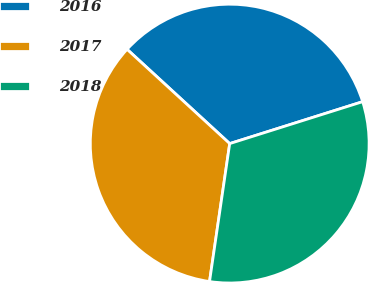Convert chart. <chart><loc_0><loc_0><loc_500><loc_500><pie_chart><fcel>2016<fcel>2017<fcel>2018<nl><fcel>33.31%<fcel>34.51%<fcel>32.17%<nl></chart> 